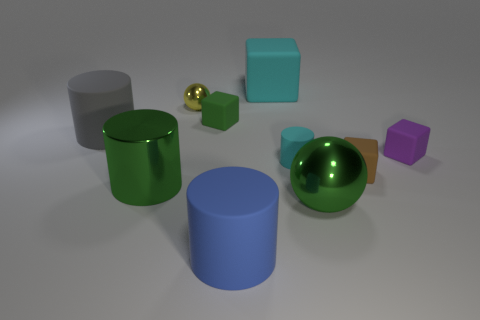Do the small cylinder and the big matte cube have the same color?
Provide a short and direct response. Yes. There is a thing that is the same color as the tiny cylinder; what material is it?
Provide a succinct answer. Rubber. Is the size of the purple block the same as the yellow metallic object?
Your answer should be compact. Yes. How many things are brown matte blocks or balls behind the large blue object?
Offer a terse response. 3. What material is the green thing that is the same size as the brown cube?
Provide a succinct answer. Rubber. The large object that is both behind the brown rubber object and right of the small metal sphere is made of what material?
Offer a very short reply. Rubber. There is a large green metal object left of the big rubber block; are there any blue things that are behind it?
Keep it short and to the point. No. There is a object that is both behind the big gray cylinder and in front of the small shiny thing; what is its size?
Offer a very short reply. Small. How many gray things are big matte cylinders or small cylinders?
Provide a succinct answer. 1. What is the shape of the brown thing that is the same size as the green matte cube?
Make the answer very short. Cube. 